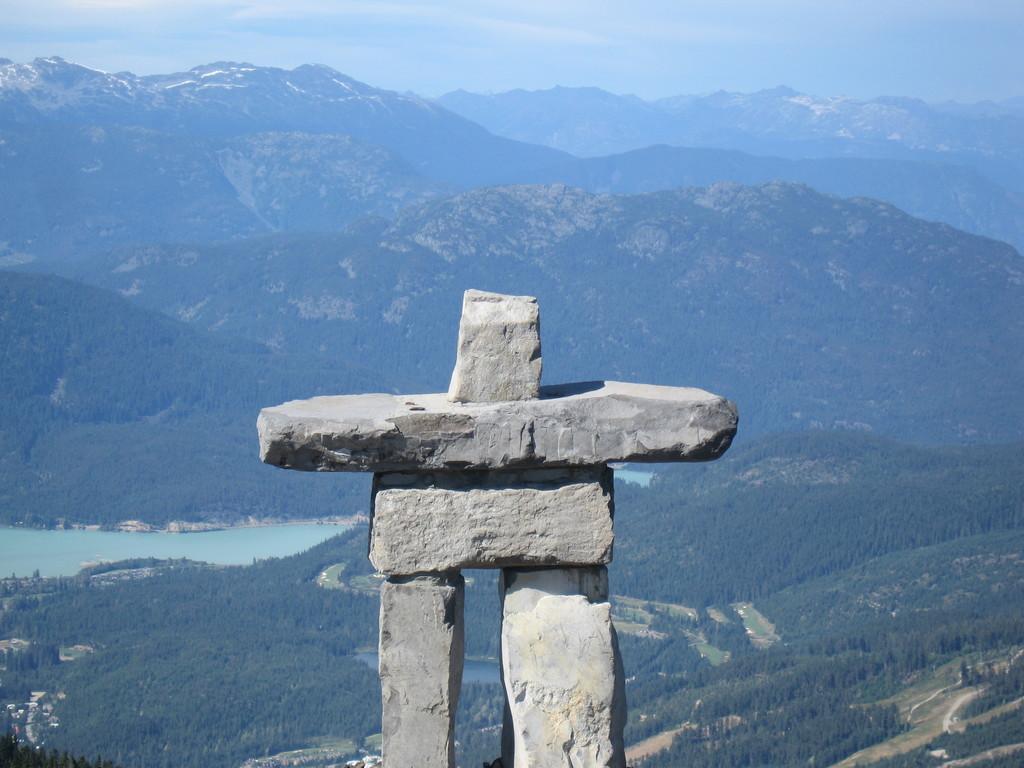Could you give a brief overview of what you see in this image? In the foreground of this image, there is a stone structure. In the background, there are trees, water, mountains and the sky. 